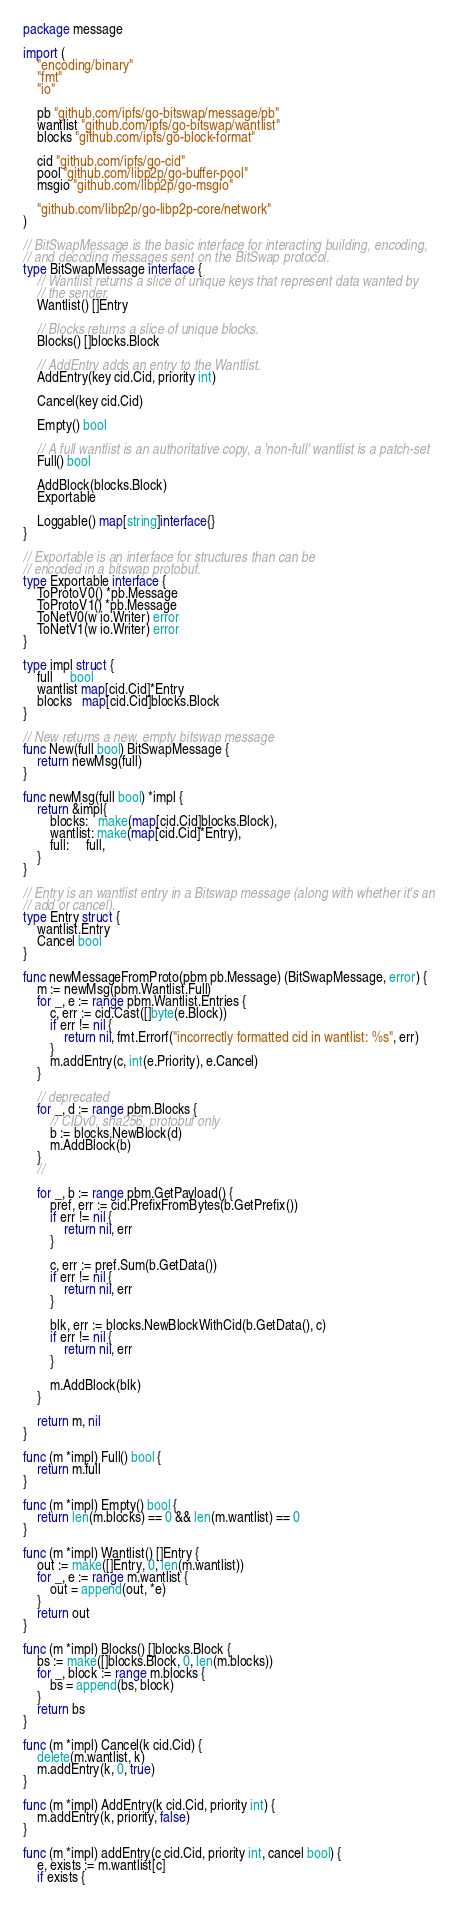<code> <loc_0><loc_0><loc_500><loc_500><_Go_>package message

import (
	"encoding/binary"
	"fmt"
	"io"

	pb "github.com/ipfs/go-bitswap/message/pb"
	wantlist "github.com/ipfs/go-bitswap/wantlist"
	blocks "github.com/ipfs/go-block-format"

	cid "github.com/ipfs/go-cid"
	pool "github.com/libp2p/go-buffer-pool"
	msgio "github.com/libp2p/go-msgio"

	"github.com/libp2p/go-libp2p-core/network"
)

// BitSwapMessage is the basic interface for interacting building, encoding,
// and decoding messages sent on the BitSwap protocol.
type BitSwapMessage interface {
	// Wantlist returns a slice of unique keys that represent data wanted by
	// the sender.
	Wantlist() []Entry

	// Blocks returns a slice of unique blocks.
	Blocks() []blocks.Block

	// AddEntry adds an entry to the Wantlist.
	AddEntry(key cid.Cid, priority int)

	Cancel(key cid.Cid)

	Empty() bool

	// A full wantlist is an authoritative copy, a 'non-full' wantlist is a patch-set
	Full() bool

	AddBlock(blocks.Block)
	Exportable

	Loggable() map[string]interface{}
}

// Exportable is an interface for structures than can be
// encoded in a bitswap protobuf.
type Exportable interface {
	ToProtoV0() *pb.Message
	ToProtoV1() *pb.Message
	ToNetV0(w io.Writer) error
	ToNetV1(w io.Writer) error
}

type impl struct {
	full     bool
	wantlist map[cid.Cid]*Entry
	blocks   map[cid.Cid]blocks.Block
}

// New returns a new, empty bitswap message
func New(full bool) BitSwapMessage {
	return newMsg(full)
}

func newMsg(full bool) *impl {
	return &impl{
		blocks:   make(map[cid.Cid]blocks.Block),
		wantlist: make(map[cid.Cid]*Entry),
		full:     full,
	}
}

// Entry is an wantlist entry in a Bitswap message (along with whether it's an
// add or cancel).
type Entry struct {
	wantlist.Entry
	Cancel bool
}

func newMessageFromProto(pbm pb.Message) (BitSwapMessage, error) {
	m := newMsg(pbm.Wantlist.Full)
	for _, e := range pbm.Wantlist.Entries {
		c, err := cid.Cast([]byte(e.Block))
		if err != nil {
			return nil, fmt.Errorf("incorrectly formatted cid in wantlist: %s", err)
		}
		m.addEntry(c, int(e.Priority), e.Cancel)
	}

	// deprecated
	for _, d := range pbm.Blocks {
		// CIDv0, sha256, protobuf only
		b := blocks.NewBlock(d)
		m.AddBlock(b)
	}
	//

	for _, b := range pbm.GetPayload() {
		pref, err := cid.PrefixFromBytes(b.GetPrefix())
		if err != nil {
			return nil, err
		}

		c, err := pref.Sum(b.GetData())
		if err != nil {
			return nil, err
		}

		blk, err := blocks.NewBlockWithCid(b.GetData(), c)
		if err != nil {
			return nil, err
		}

		m.AddBlock(blk)
	}

	return m, nil
}

func (m *impl) Full() bool {
	return m.full
}

func (m *impl) Empty() bool {
	return len(m.blocks) == 0 && len(m.wantlist) == 0
}

func (m *impl) Wantlist() []Entry {
	out := make([]Entry, 0, len(m.wantlist))
	for _, e := range m.wantlist {
		out = append(out, *e)
	}
	return out
}

func (m *impl) Blocks() []blocks.Block {
	bs := make([]blocks.Block, 0, len(m.blocks))
	for _, block := range m.blocks {
		bs = append(bs, block)
	}
	return bs
}

func (m *impl) Cancel(k cid.Cid) {
	delete(m.wantlist, k)
	m.addEntry(k, 0, true)
}

func (m *impl) AddEntry(k cid.Cid, priority int) {
	m.addEntry(k, priority, false)
}

func (m *impl) addEntry(c cid.Cid, priority int, cancel bool) {
	e, exists := m.wantlist[c]
	if exists {</code> 